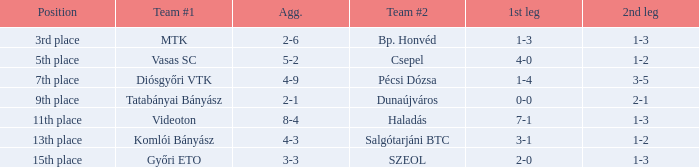What is the 1st leg of bp. honvéd team #2? 1-3. 